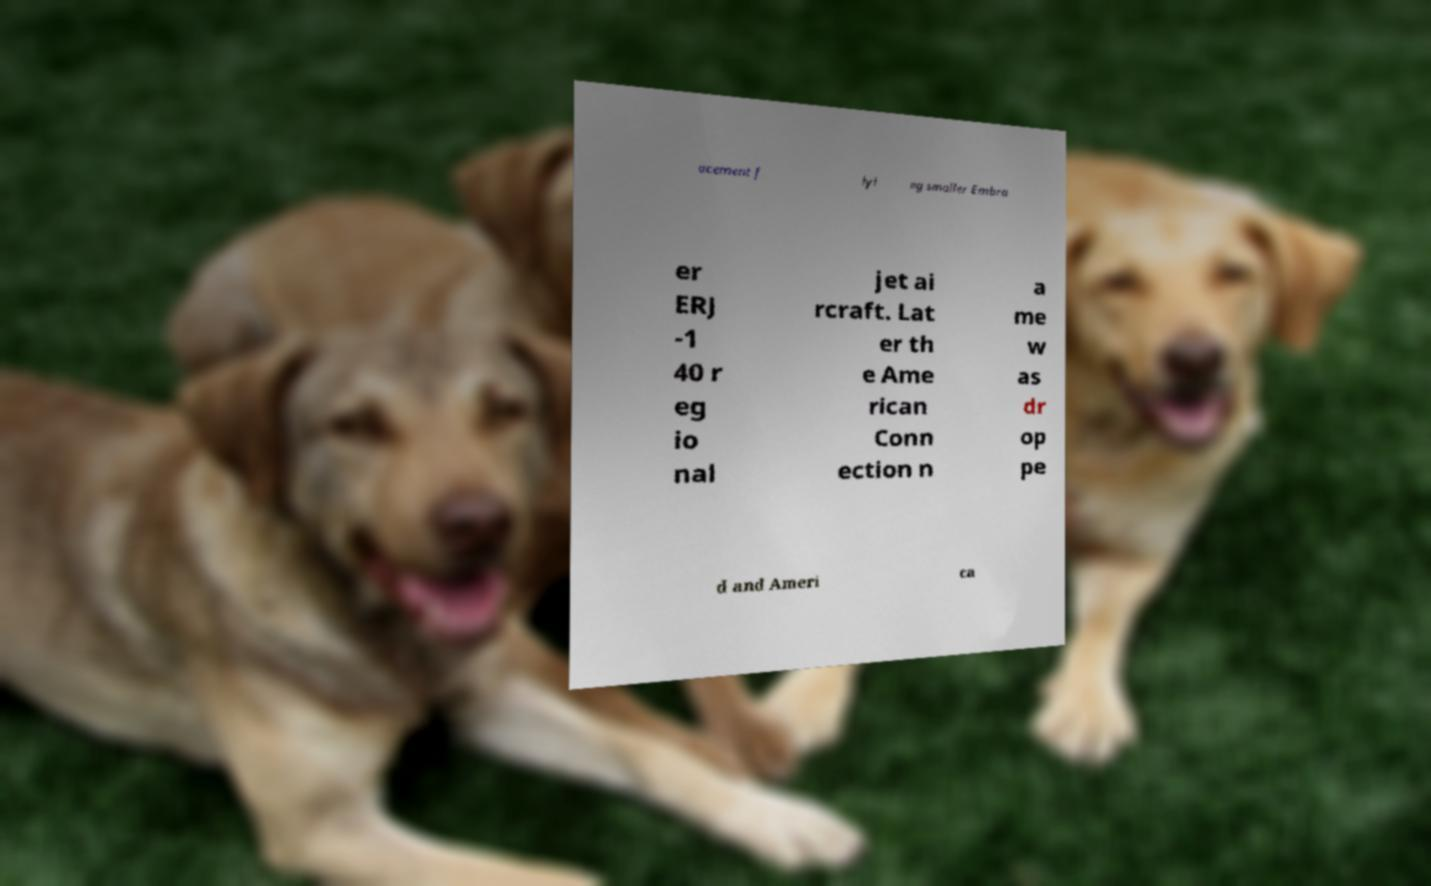What messages or text are displayed in this image? I need them in a readable, typed format. acement f lyi ng smaller Embra er ERJ -1 40 r eg io nal jet ai rcraft. Lat er th e Ame rican Conn ection n a me w as dr op pe d and Ameri ca 